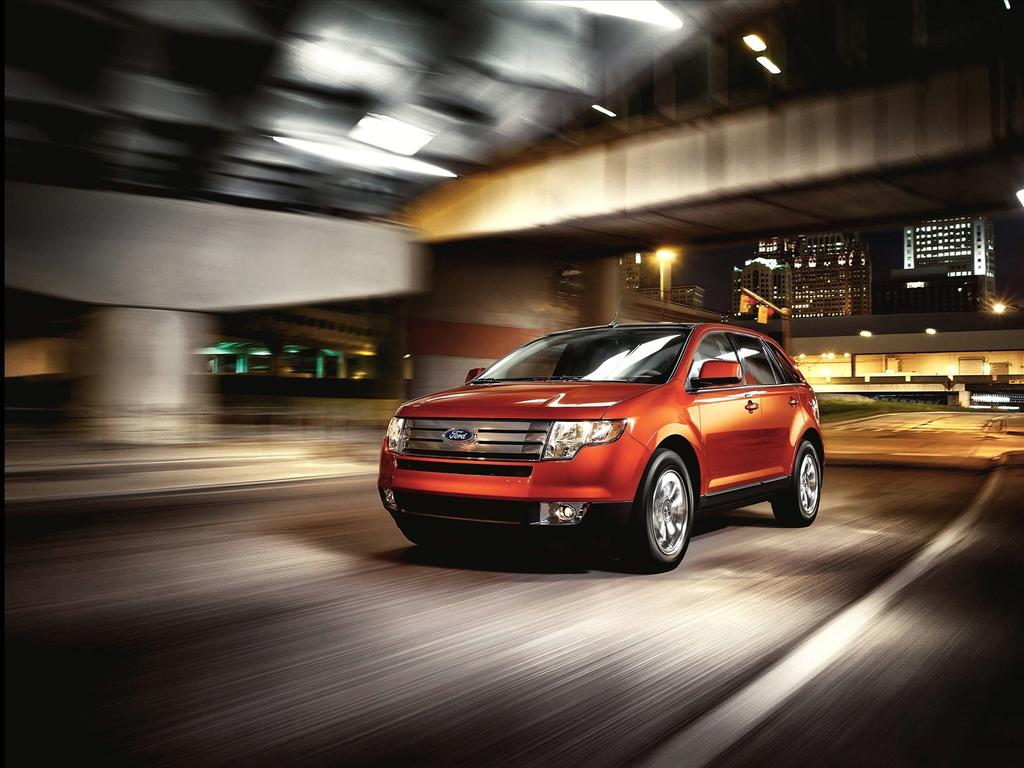What is the main subject of the image? The main subject of the image is a car. What is the car doing in the image? The car is moving on a road in the image. What can be seen in the background of the image? There are buildings in the background of the image. Can you describe the quality of the image? The top part of the image is blurred. What type of connection can be seen between the car and the clam in the image? There is no clam present in the image, so there cannot be any connection between the car and a clam. 